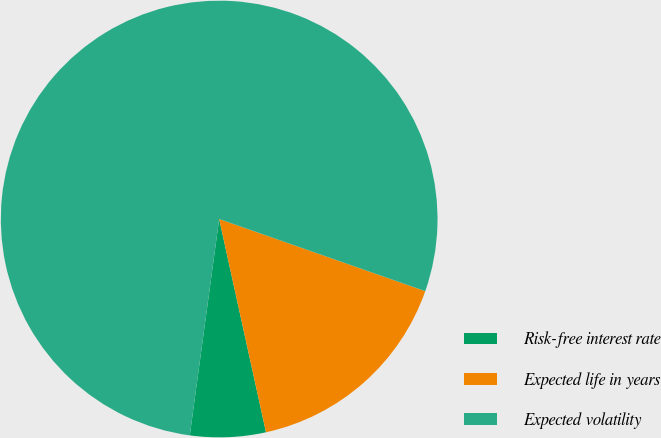Convert chart to OTSL. <chart><loc_0><loc_0><loc_500><loc_500><pie_chart><fcel>Risk-free interest rate<fcel>Expected life in years<fcel>Expected volatility<nl><fcel>5.59%<fcel>16.2%<fcel>78.21%<nl></chart> 